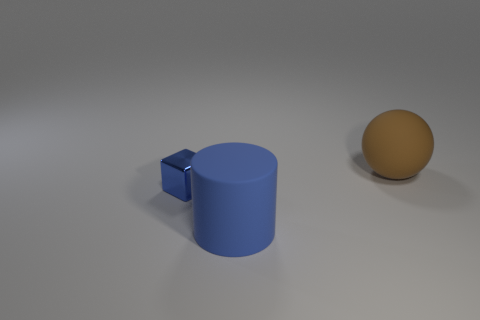Are there an equal number of metallic blocks right of the small blue metal cube and tiny blue things?
Provide a succinct answer. No. There is a large cylinder; is its color the same as the tiny shiny cube in front of the big brown thing?
Offer a very short reply. Yes. There is a thing that is both behind the matte cylinder and right of the tiny shiny block; what color is it?
Provide a short and direct response. Brown. How many big matte cylinders are right of the object to the left of the blue rubber thing?
Ensure brevity in your answer.  1. Are there any large brown things that have the same shape as the tiny blue thing?
Your answer should be compact. No. What number of things are either shiny things or small green matte cubes?
Offer a terse response. 1. Are there more balls that are on the right side of the small thing than tiny cyan metal objects?
Make the answer very short. Yes. Is the big ball made of the same material as the small thing?
Your answer should be compact. No. What number of things are either big matte cylinders left of the sphere or large rubber objects that are in front of the big brown rubber ball?
Your answer should be compact. 1. What number of big rubber cylinders have the same color as the metal block?
Ensure brevity in your answer.  1. 